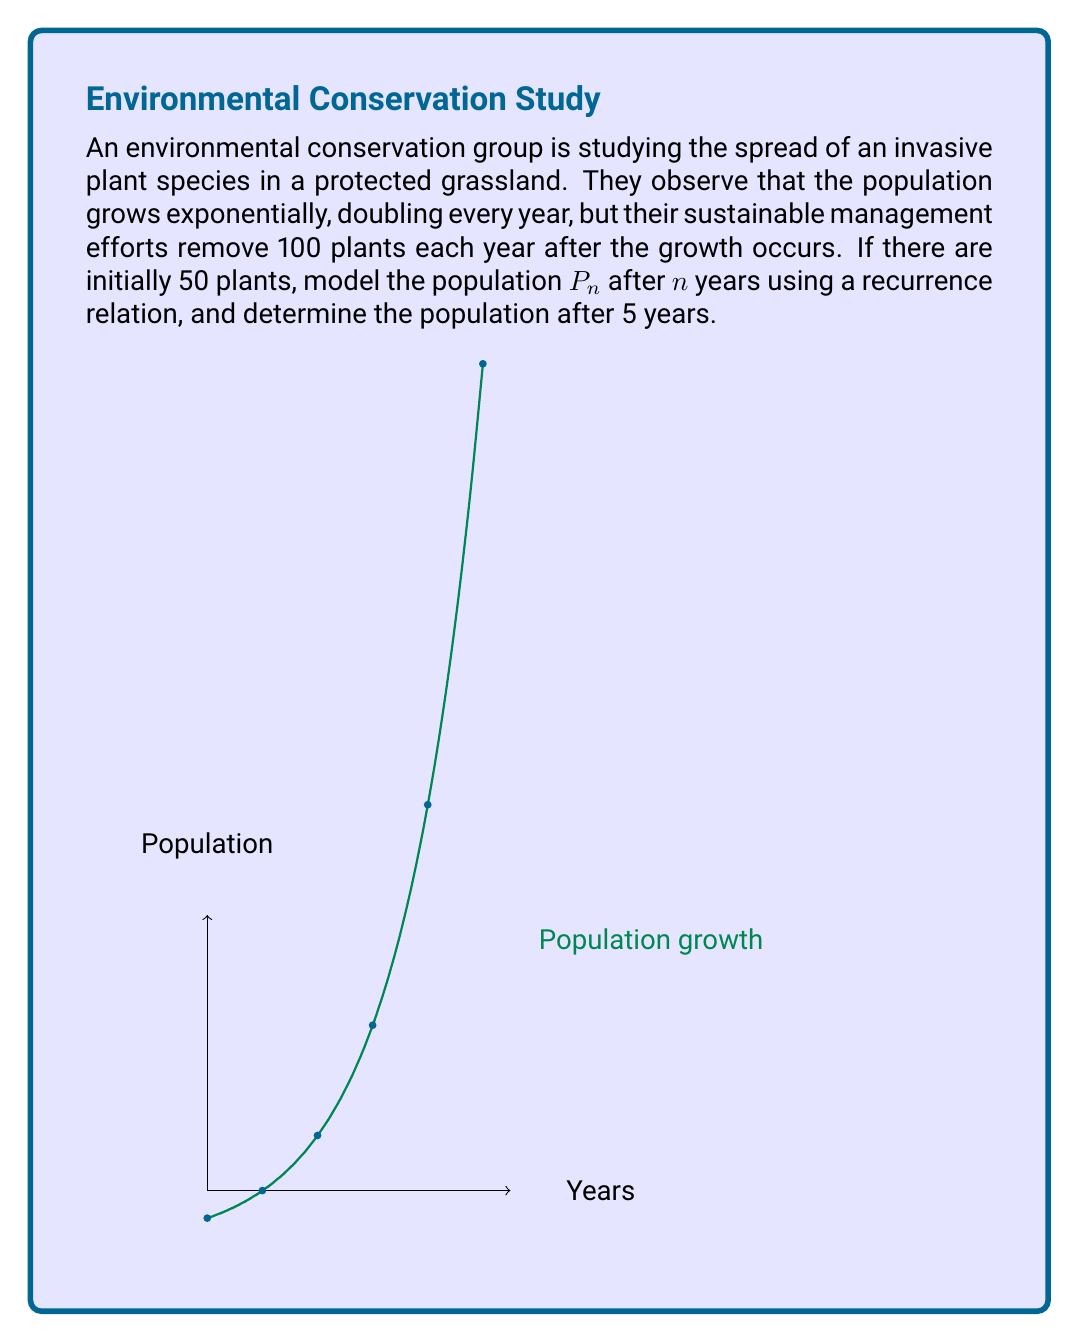Help me with this question. Let's approach this step-by-step:

1) First, we need to formulate the recurrence relation. Let $P_n$ be the population after $n$ years.

2) The population doubles each year, so without removal, we'd have:
   $P_n = 2P_{n-1}$

3) However, 100 plants are removed each year after growth. So our recurrence relation becomes:
   $P_n = 2P_{n-1} - 100$

4) We're given that $P_0 = 50$ (initial population).

5) Now, let's calculate the population for each year:

   Year 1: $P_1 = 2(50) - 100 = 0$
   Year 2: $P_2 = 2(0) - 100 = -100$
   Year 3: $P_3 = 2(-100) - 100 = -300$
   Year 4: $P_4 = 2(-300) - 100 = -700$
   Year 5: $P_5 = 2(-700) - 100 = -1500$

6) We can also derive a closed-form solution for this recurrence relation:
   $P_n = 50 \cdot 2^n - 100 \cdot \frac{2^n - 1}{2-1} = 50 \cdot 2^n - 100(2^n - 1)$

7) Using this formula for $n = 5$:
   $P_5 = 50 \cdot 2^5 - 100(2^5 - 1) = 1600 - 3100 = -1500$

This confirms our step-by-step calculation.
Answer: $P_5 = -1500$ plants 